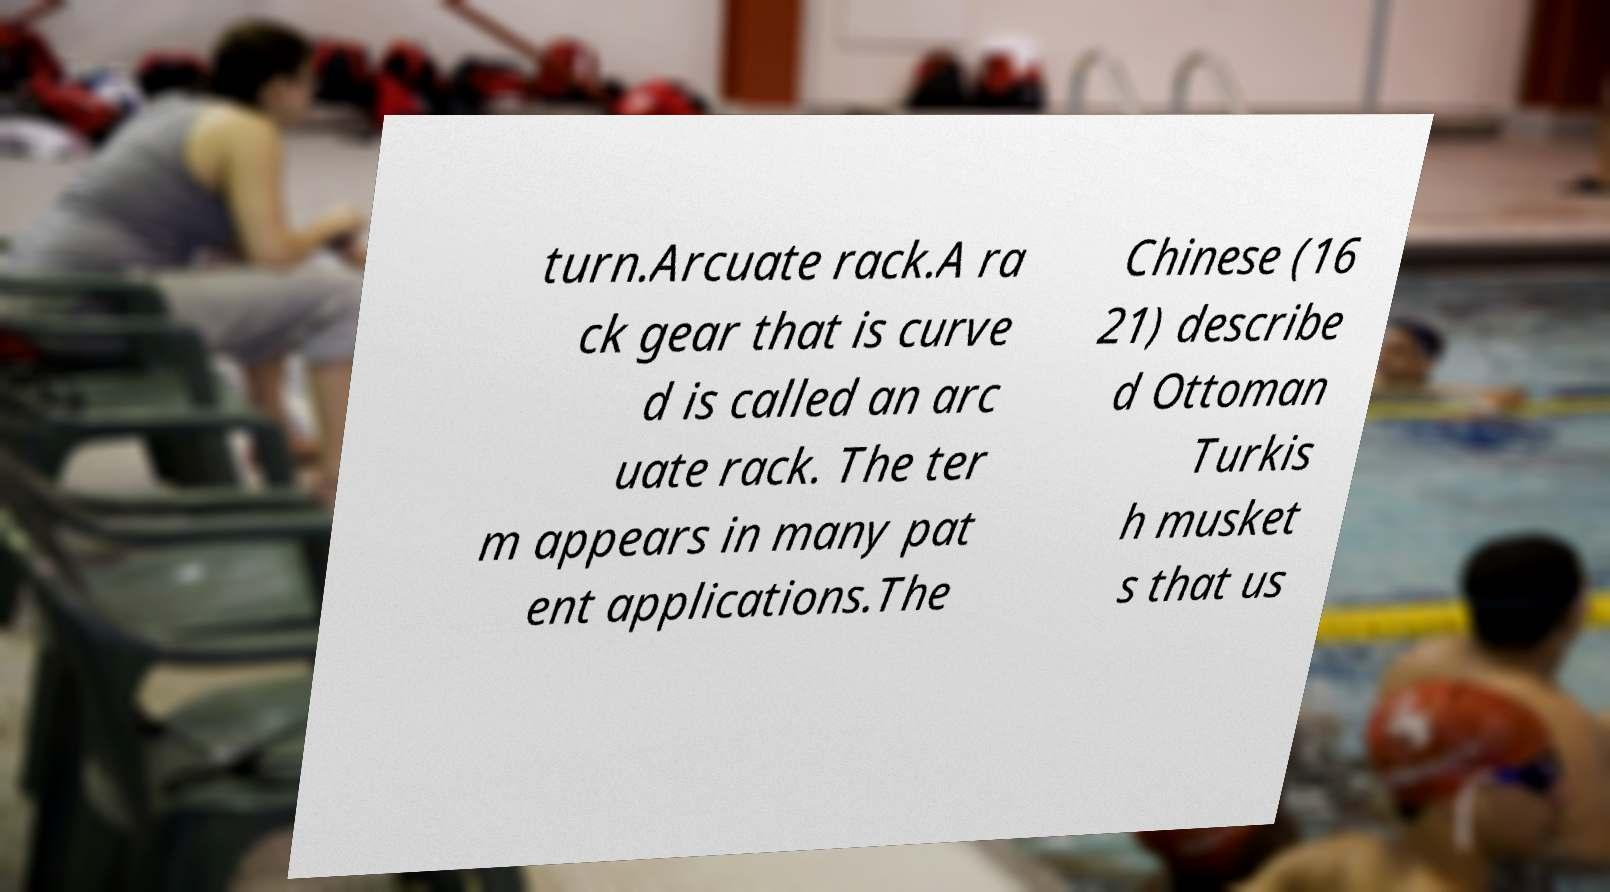Please read and relay the text visible in this image. What does it say? turn.Arcuate rack.A ra ck gear that is curve d is called an arc uate rack. The ter m appears in many pat ent applications.The Chinese (16 21) describe d Ottoman Turkis h musket s that us 